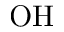Convert formula to latex. <formula><loc_0><loc_0><loc_500><loc_500>O H</formula> 